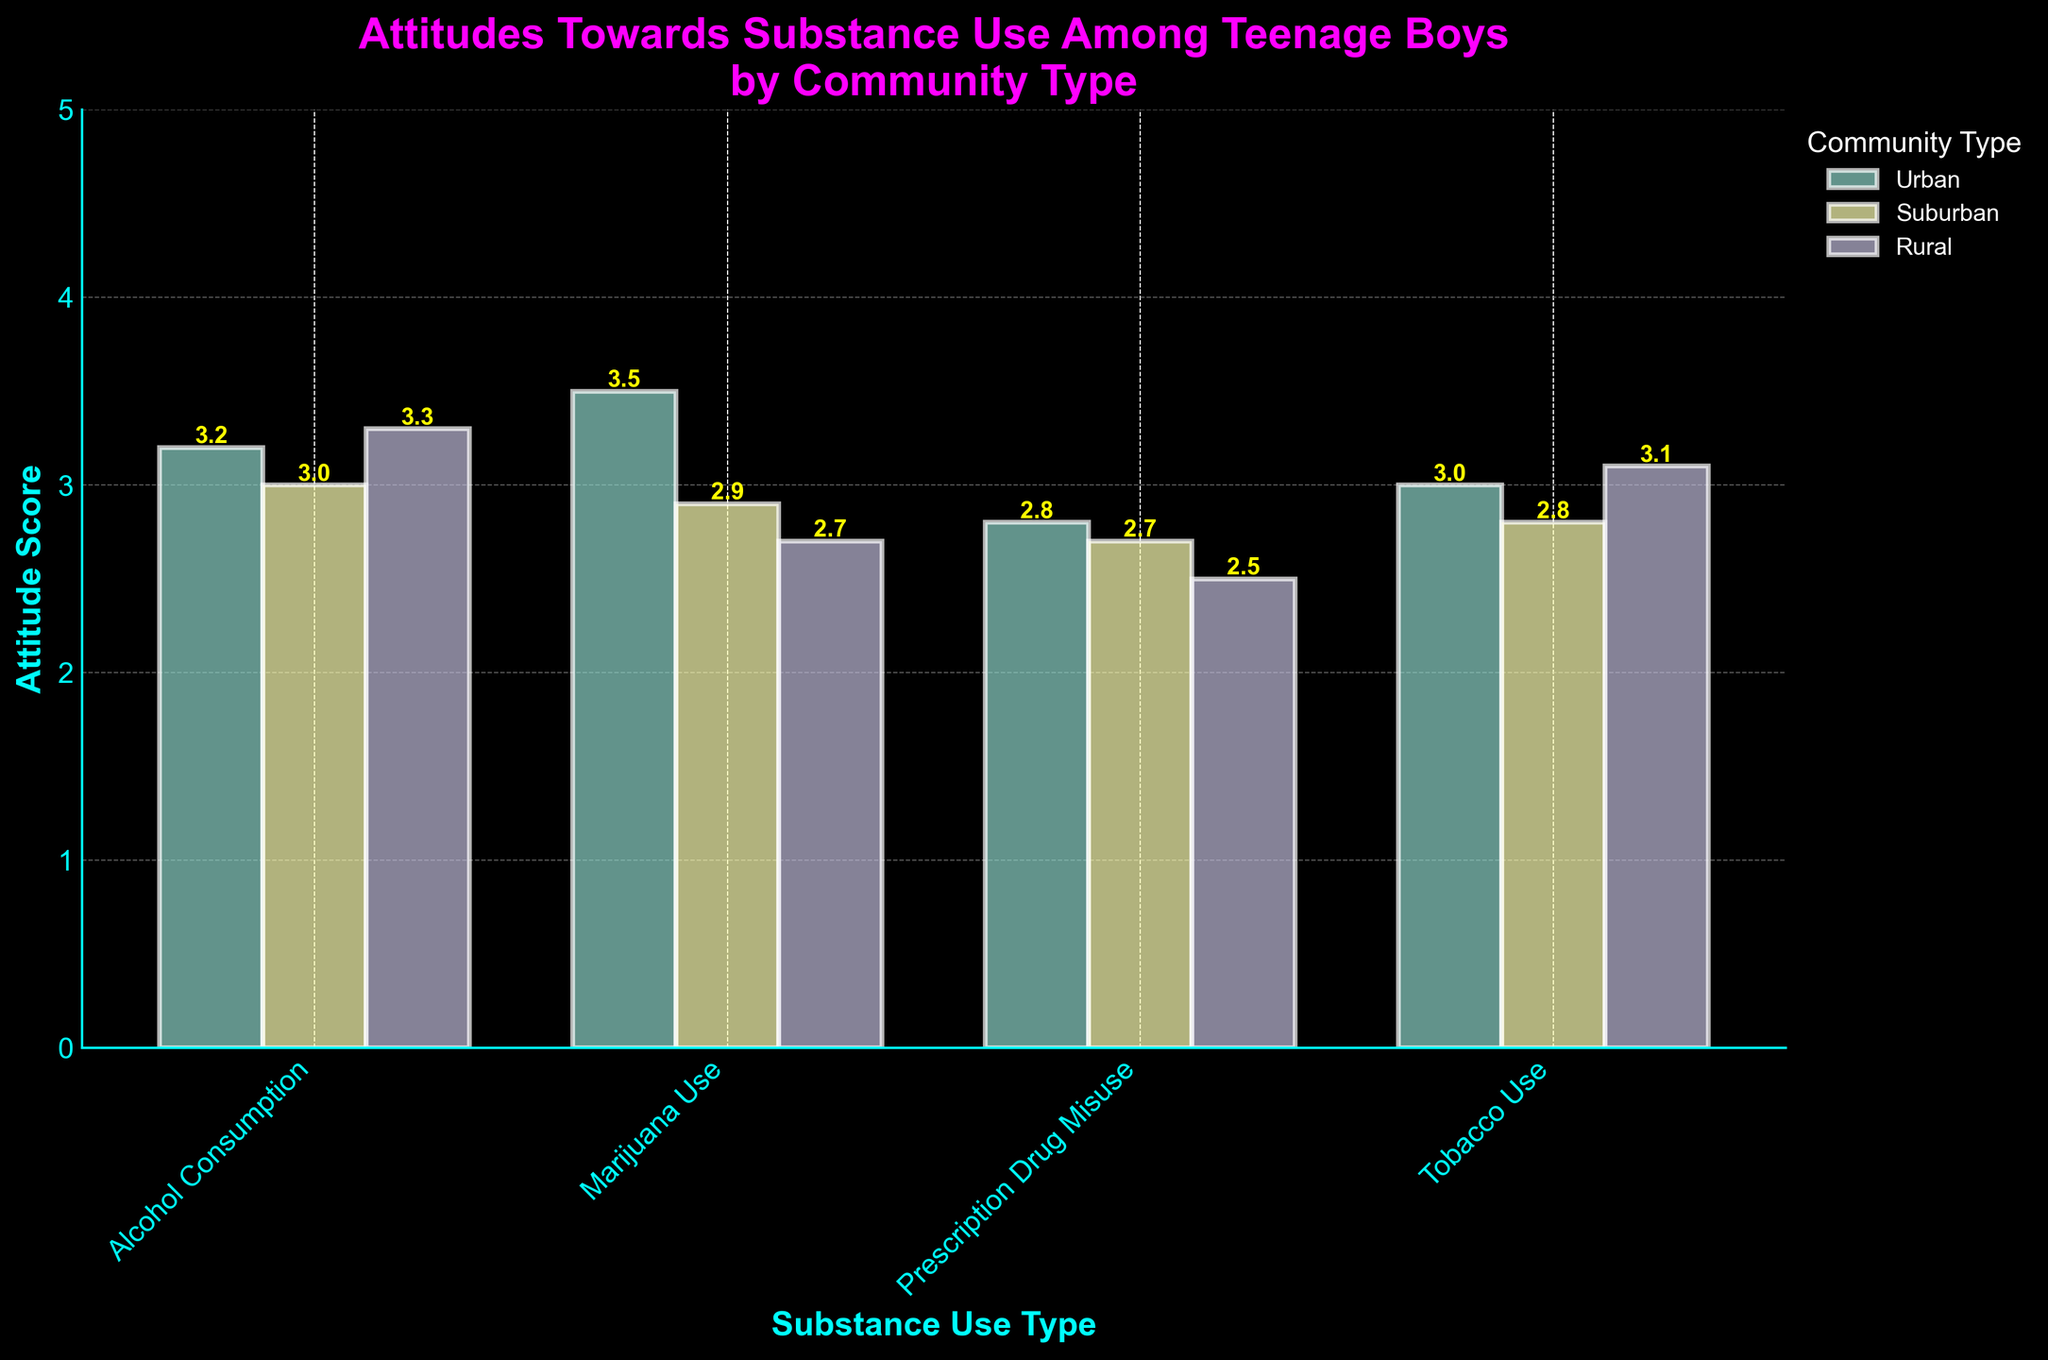What is the title of the figure? The title of the figure is displayed at the top and reads "Attitudes Towards Substance Use Among Teenage Boys by Community Type". This can be confirmed by looking at the largest text at the top of the figure.
Answer: Attitudes Towards Substance Use Among Teenage Boys by Community Type What are the four types of substances shown on the x-axis? The x-axis of the figure lists four substances: Alcohol Consumption, Marijuana Use, Prescription Drug Misuse, and Tobacco Use. This can be confirmed by reading the labels along the x-axis.
Answer: Alcohol Consumption, Marijuana Use, Prescription Drug Misuse, Tobacco Use What is the mean attitude score for Marijuana Use in urban communities? To find this, look at the bar labeled "Marijuana Use" for the urban community, which is the first bar group. The height of this bar is labeled with the value 3.5.
Answer: 3.5 Which community type has the highest mean attitude score for Tobacco Use? Compare the heights and labels of the bars for Tobacco Use across all community types. The Rural community has the highest mean score at 3.1.
Answer: Rural What is the range of the error bars for Alcohol Consumption in suburban communities? Examine the error bar for the Alcohol Consumption in suburban communities. The mean is 3.0 with a standard deviation of 0.7, so the range is from 3.0 - 0.7 to 3.0 + 0.7, i.e., 2.3 to 3.7.
Answer: 2.3 to 3.7 How do the mean attitude scores for Prescription Drug Misuse compare between urban and suburban communities? The heights of the bars indicate the mean scores. For Prescription Drug Misuse, the urban mean is 2.8 and the suburban mean is 2.7. Comparing these, the urban mean is slightly higher.
Answer: Urban is slightly higher What is the difference in mean attitude scores towards Marijuana Use between suburban and rural communities? The mean attitude scores are 2.9 for suburban and 2.7 for rural. The difference is calculated as 2.9 - 2.7 = 0.2.
Answer: 0.2 Which substance has the lowest mean attitude score in rural communities? Check the heights of the bars for rural communities. The shortest bar represents Prescription Drug Misuse with a mean attitude score of 2.5.
Answer: Prescription Drug Misuse What is the average mean attitude score for Tobacco Use across all communities? Add the mean scores for Tobacco Use: (3.0 for Urban + 2.8 for Suburban + 3.1 for Rural) and divide by 3 to get the average: (3.0 + 2.8 + 3.1) / 3 = 2.97.
Answer: 2.97 Are the error bars wider for Alcohol Consumption or Marijuana Use in rural communities? The error bars represent standard deviations. For Alcohol Consumption, it's 0.9, and for Marijuana Use, it's 0.6. The error bars for Alcohol Consumption are wider.
Answer: Alcohol Consumption 